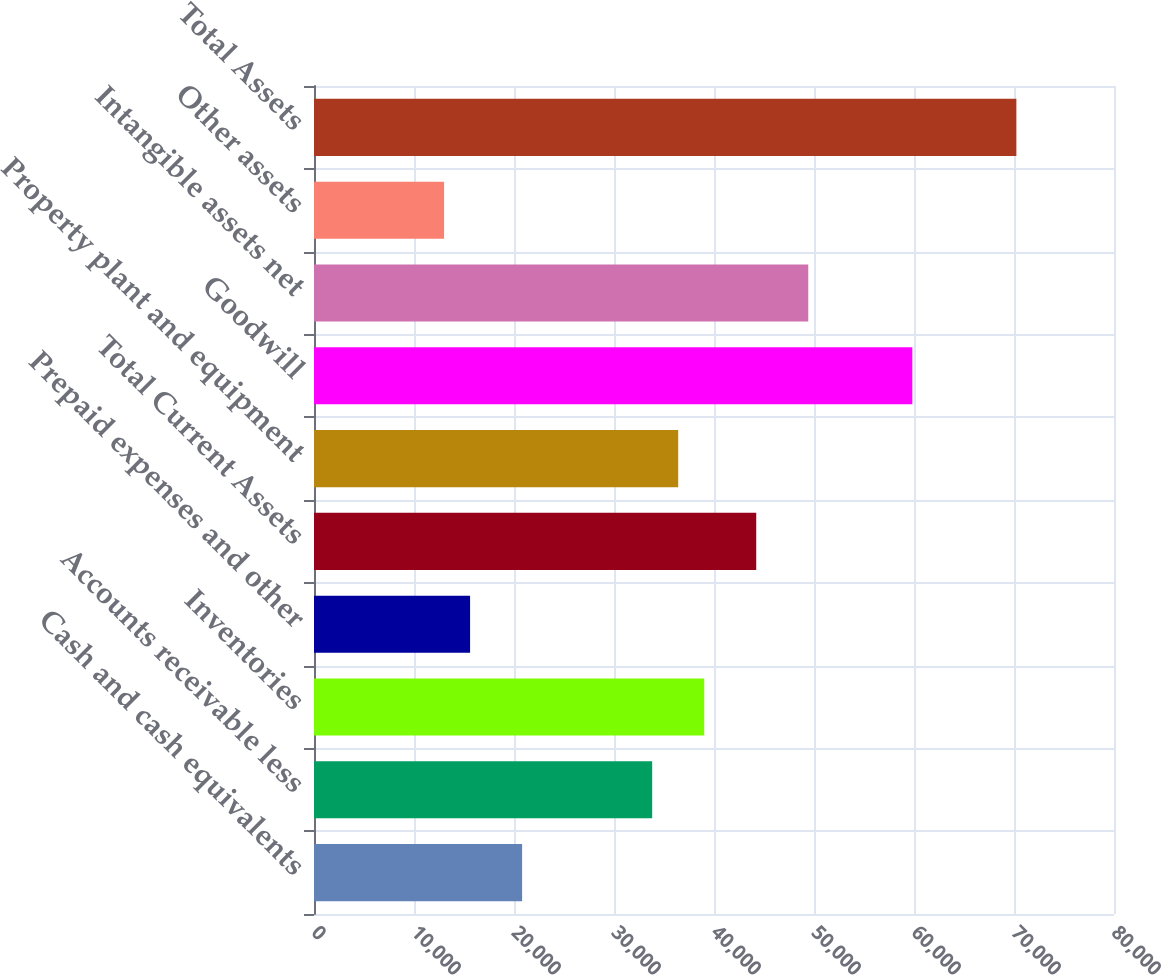Convert chart. <chart><loc_0><loc_0><loc_500><loc_500><bar_chart><fcel>Cash and cash equivalents<fcel>Accounts receivable less<fcel>Inventories<fcel>Prepaid expenses and other<fcel>Total Current Assets<fcel>Property plant and equipment<fcel>Goodwill<fcel>Intangible assets net<fcel>Other assets<fcel>Total Assets<nl><fcel>20811.3<fcel>33818.1<fcel>39020.8<fcel>15608.5<fcel>44223.6<fcel>36419.5<fcel>59831.8<fcel>49426.3<fcel>13007.1<fcel>70237.3<nl></chart> 